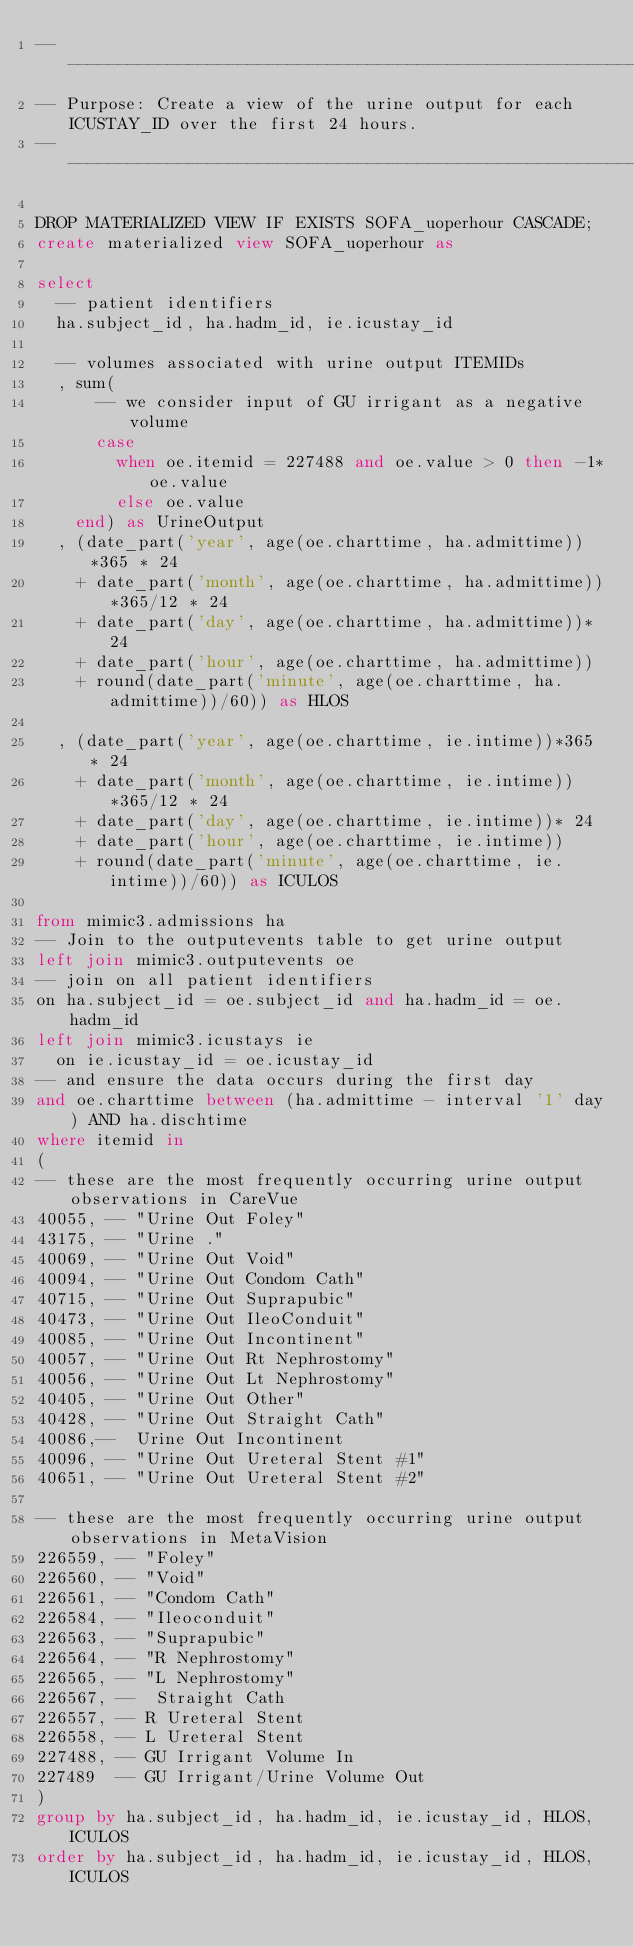<code> <loc_0><loc_0><loc_500><loc_500><_SQL_>-- ------------------------------------------------------------------
-- Purpose: Create a view of the urine output for each ICUSTAY_ID over the first 24 hours.
-- ------------------------------------------------------------------

DROP MATERIALIZED VIEW IF EXISTS SOFA_uoperhour CASCADE;
create materialized view SOFA_uoperhour as

select
  -- patient identifiers
  ha.subject_id, ha.hadm_id, ie.icustay_id

  -- volumes associated with urine output ITEMIDs
  , sum(
      -- we consider input of GU irrigant as a negative volume
      case
        when oe.itemid = 227488 and oe.value > 0 then -1*oe.value
        else oe.value
    end) as UrineOutput
  , (date_part('year', age(oe.charttime, ha.admittime))*365 * 24
    + date_part('month', age(oe.charttime, ha.admittime))*365/12 * 24
    + date_part('day', age(oe.charttime, ha.admittime))* 24
    + date_part('hour', age(oe.charttime, ha.admittime))
    + round(date_part('minute', age(oe.charttime, ha.admittime))/60)) as HLOS

  , (date_part('year', age(oe.charttime, ie.intime))*365 * 24
    + date_part('month', age(oe.charttime, ie.intime))*365/12 * 24
    + date_part('day', age(oe.charttime, ie.intime))* 24
    + date_part('hour', age(oe.charttime, ie.intime))
    + round(date_part('minute', age(oe.charttime, ie.intime))/60)) as ICULOS

from mimic3.admissions ha
-- Join to the outputevents table to get urine output
left join mimic3.outputevents oe
-- join on all patient identifiers
on ha.subject_id = oe.subject_id and ha.hadm_id = oe.hadm_id
left join mimic3.icustays ie
  on ie.icustay_id = oe.icustay_id
-- and ensure the data occurs during the first day
and oe.charttime between (ha.admittime - interval '1' day) AND ha.dischtime
where itemid in
(
-- these are the most frequently occurring urine output observations in CareVue
40055, -- "Urine Out Foley"
43175, -- "Urine ."
40069, -- "Urine Out Void"
40094, -- "Urine Out Condom Cath"
40715, -- "Urine Out Suprapubic"
40473, -- "Urine Out IleoConduit"
40085, -- "Urine Out Incontinent"
40057, -- "Urine Out Rt Nephrostomy"
40056, -- "Urine Out Lt Nephrostomy"
40405, -- "Urine Out Other"
40428, -- "Urine Out Straight Cath"
40086,--	Urine Out Incontinent
40096, -- "Urine Out Ureteral Stent #1"
40651, -- "Urine Out Ureteral Stent #2"

-- these are the most frequently occurring urine output observations in MetaVision
226559, -- "Foley"
226560, -- "Void"
226561, -- "Condom Cath"
226584, -- "Ileoconduit"
226563, -- "Suprapubic"
226564, -- "R Nephrostomy"
226565, -- "L Nephrostomy"
226567, --	Straight Cath
226557, -- R Ureteral Stent
226558, -- L Ureteral Stent
227488, -- GU Irrigant Volume In
227489  -- GU Irrigant/Urine Volume Out
)
group by ha.subject_id, ha.hadm_id, ie.icustay_id, HLOS, ICULOS
order by ha.subject_id, ha.hadm_id, ie.icustay_id, HLOS, ICULOS</code> 